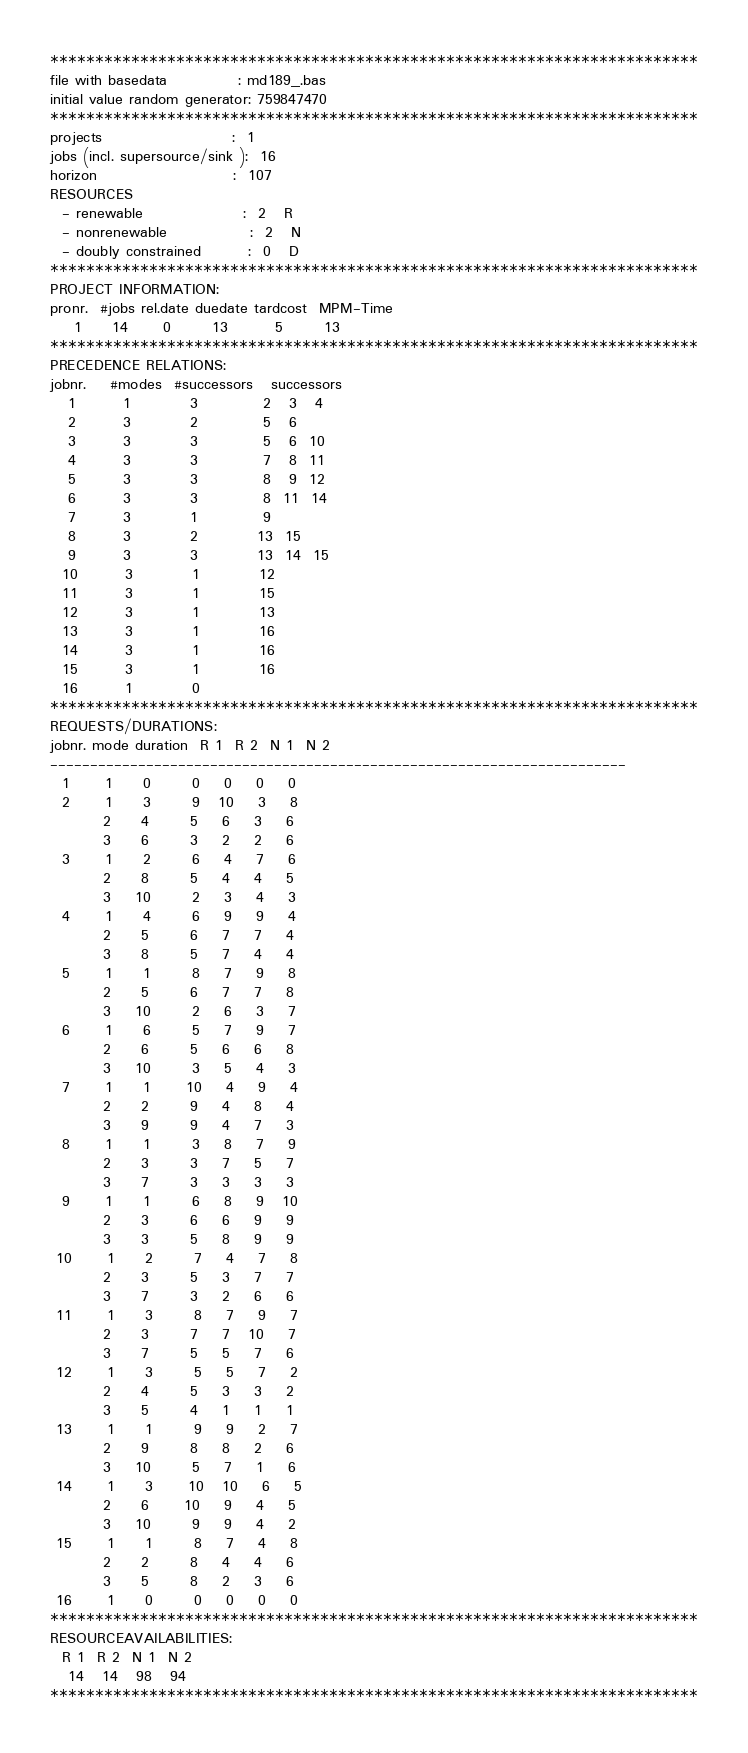<code> <loc_0><loc_0><loc_500><loc_500><_ObjectiveC_>************************************************************************
file with basedata            : md189_.bas
initial value random generator: 759847470
************************************************************************
projects                      :  1
jobs (incl. supersource/sink ):  16
horizon                       :  107
RESOURCES
  - renewable                 :  2   R
  - nonrenewable              :  2   N
  - doubly constrained        :  0   D
************************************************************************
PROJECT INFORMATION:
pronr.  #jobs rel.date duedate tardcost  MPM-Time
    1     14      0       13        5       13
************************************************************************
PRECEDENCE RELATIONS:
jobnr.    #modes  #successors   successors
   1        1          3           2   3   4
   2        3          2           5   6
   3        3          3           5   6  10
   4        3          3           7   8  11
   5        3          3           8   9  12
   6        3          3           8  11  14
   7        3          1           9
   8        3          2          13  15
   9        3          3          13  14  15
  10        3          1          12
  11        3          1          15
  12        3          1          13
  13        3          1          16
  14        3          1          16
  15        3          1          16
  16        1          0        
************************************************************************
REQUESTS/DURATIONS:
jobnr. mode duration  R 1  R 2  N 1  N 2
------------------------------------------------------------------------
  1      1     0       0    0    0    0
  2      1     3       9   10    3    8
         2     4       5    6    3    6
         3     6       3    2    2    6
  3      1     2       6    4    7    6
         2     8       5    4    4    5
         3    10       2    3    4    3
  4      1     4       6    9    9    4
         2     5       6    7    7    4
         3     8       5    7    4    4
  5      1     1       8    7    9    8
         2     5       6    7    7    8
         3    10       2    6    3    7
  6      1     6       5    7    9    7
         2     6       5    6    6    8
         3    10       3    5    4    3
  7      1     1      10    4    9    4
         2     2       9    4    8    4
         3     9       9    4    7    3
  8      1     1       3    8    7    9
         2     3       3    7    5    7
         3     7       3    3    3    3
  9      1     1       6    8    9   10
         2     3       6    6    9    9
         3     3       5    8    9    9
 10      1     2       7    4    7    8
         2     3       5    3    7    7
         3     7       3    2    6    6
 11      1     3       8    7    9    7
         2     3       7    7   10    7
         3     7       5    5    7    6
 12      1     3       5    5    7    2
         2     4       5    3    3    2
         3     5       4    1    1    1
 13      1     1       9    9    2    7
         2     9       8    8    2    6
         3    10       5    7    1    6
 14      1     3      10   10    6    5
         2     6      10    9    4    5
         3    10       9    9    4    2
 15      1     1       8    7    4    8
         2     2       8    4    4    6
         3     5       8    2    3    6
 16      1     0       0    0    0    0
************************************************************************
RESOURCEAVAILABILITIES:
  R 1  R 2  N 1  N 2
   14   14   98   94
************************************************************************
</code> 